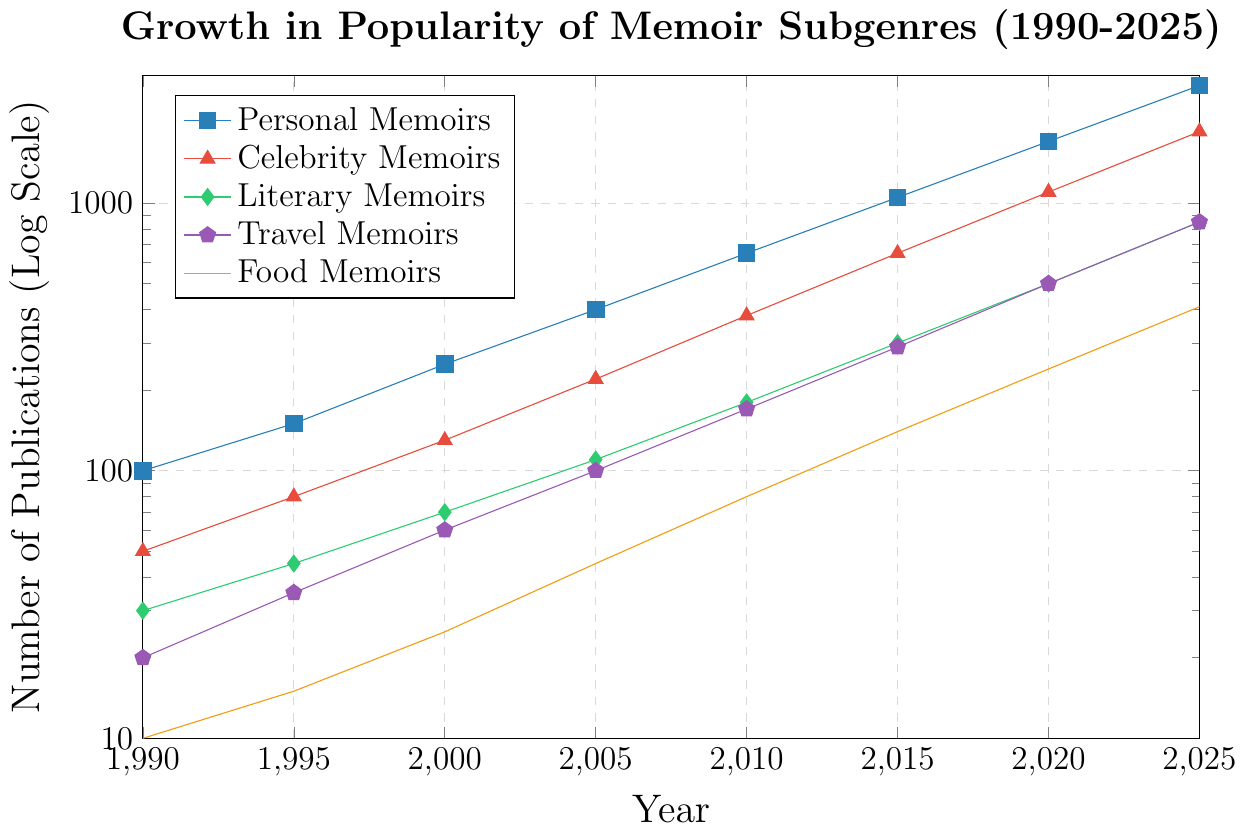What subgenre had the highest growth in popularity between 1990 and 2025? To determine this, we need to calculate the difference in the number of publications between 1990 and 2025 for each subgenre. For Personal Memoirs, the growth is 2750 - 100 = 2650; for Celebrity Memoirs, it is 1850 - 50 = 1800; for Literary Memoirs, it is 850 - 30 = 820; for Travel Memoirs, it is 850 - 20 = 830; for Food Memoirs, it is 410 - 10 = 400. The highest growth is seen in Personal Memoirs with an increase of 2650.
Answer: Personal Memoirs Which subgenre had the fewest publications in 2010? From the figure, identify the data points for 2010 for each subgenre. The values are: Personal Memoirs (650), Celebrity Memoirs (380), Literary Memoirs (180), Travel Memoirs (170), and Food Memoirs (80). The fewest publications in 2010 were in Food Memoirs.
Answer: Food Memoirs By what factor did the number of Travel Memoirs publications increase from 1990 to 2020? Record the number of Travel Memoirs in 1990 (20) and 2020 (500). The factor of increase is calculated as 500 / 20 = 25.
Answer: 25 Compare the growth rates between Literary Memoirs and Celebrity Memoirs from 2000 to 2015. Which one grew faster? Determine the growth for each subgenre: Literary Memoirs from 70 to 300 (300 - 70 = 230), and Celebrity Memoirs from 130 to 650 (650 - 130 = 520). Celebrity Memoirs had a higher increase in number, hence it grew faster.
Answer: Celebrity Memoirs How many more Personal Memoirs were published compared to Literary Memoirs in 2025? The value for Personal Memoirs in 2025 is 2750 and for Literary Memoirs is 850. The difference is 2750 - 850 = 1900.
Answer: 1900 In which year did the number of Food Memoirs publications reach 100 or more for the first time? Examine the values for Food Memoirs over the years: 1990 (10), 1995 (15), 2000 (25), 2005 (45), 2010 (80), 2015 (140). The first year it reaches 100 or more is 2015.
Answer: 2015 What was the average number of Celebrity Memoirs published per year from 1990 to 1995? The values from 1990 to 1995 are 50 and 80. Average is calculated as (50 + 80) / 2 = 65.
Answer: 65 Which subgenre had the closest rate of publication increase to Food Memoirs between 2005 and 2020? Calculate the increase for each subgenre: Food Memoirs (240 - 45 = 195), Personal Memoirs (1700 - 400 = 1300), Celebrity Memoirs (1100 - 220 = 880), Literary Memoirs (500 - 110 = 390), Travel Memoirs (500 - 100 = 400). The closest increase to 195 is for Literary Memoirs with 390 - 195 = 195.
Answer: Literary Memoirs What are the publication counts for Travel Memoirs and Food Memoirs in 2025, and which one had more publications? Identify the values for 2025: Travel Memoirs (850), Food Memoirs (410). Travel Memoirs had more publications.
Answer: Travel Memoirs 